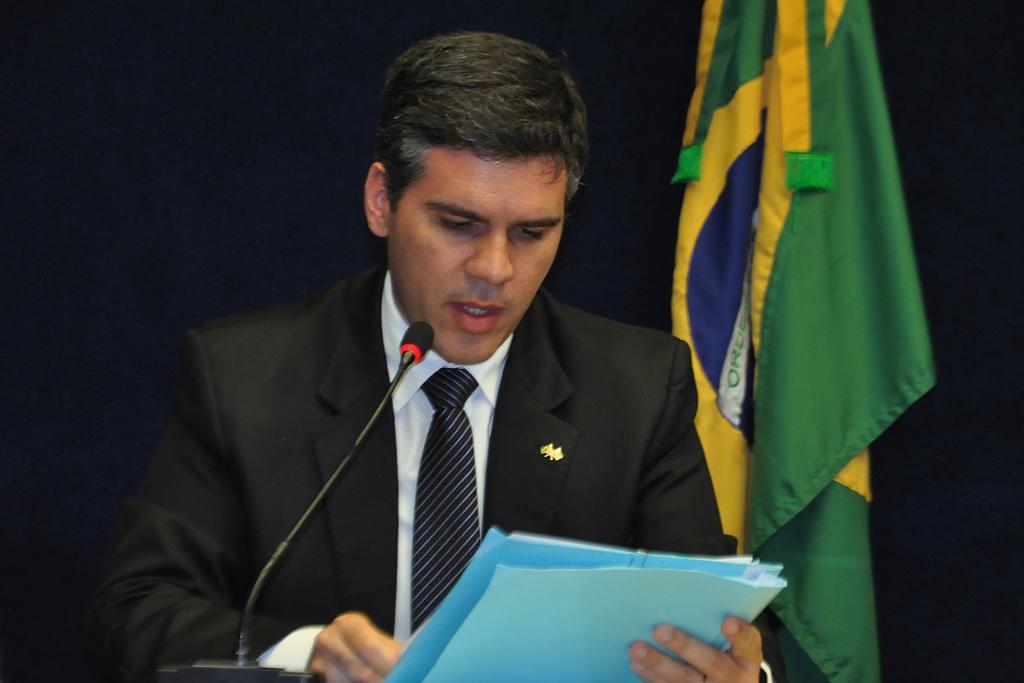Could you give a brief overview of what you see in this image? In this picture we can see a man, he is holding a file, in front of him we can see a microphone, in the background we can find a flag. 